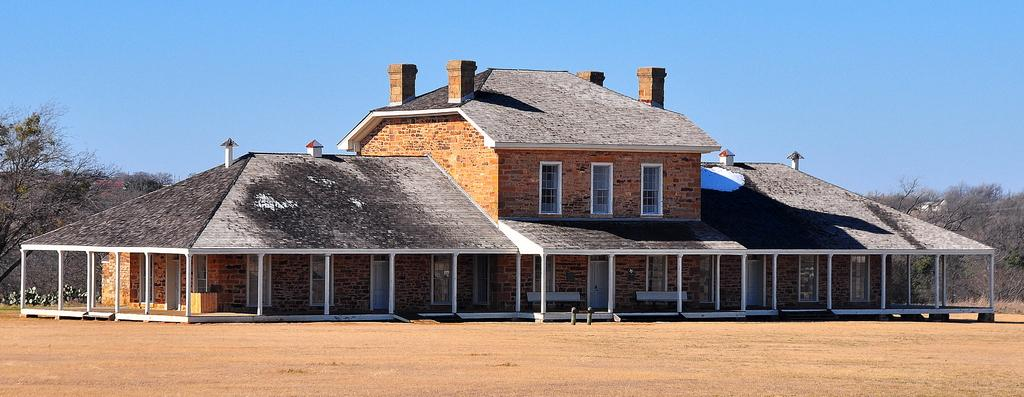What type of structure is in the image? There is a building in the image. What features can be seen on the building? The building has windows and doors. What can be seen in the background of the image? There are trees in the background of the image. What is visible at the top of the image? The sky is visible at the top of the image. What is visible at the bottom of the image? The land is visible at the bottom of the image. How many spiders are crawling on the building in the image? There are no spiders visible in the image; the focus is on the building and its features. What type of train can be seen passing by the building in the image? There is no train present in the image; the focus is on the building and its surroundings. 